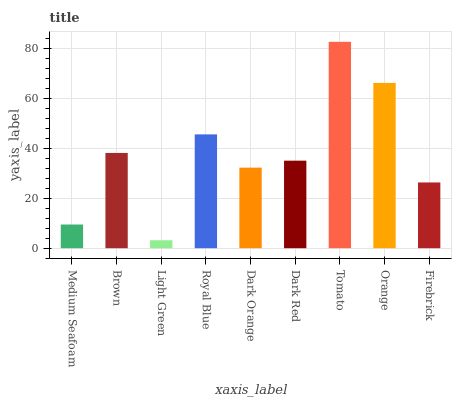Is Light Green the minimum?
Answer yes or no. Yes. Is Tomato the maximum?
Answer yes or no. Yes. Is Brown the minimum?
Answer yes or no. No. Is Brown the maximum?
Answer yes or no. No. Is Brown greater than Medium Seafoam?
Answer yes or no. Yes. Is Medium Seafoam less than Brown?
Answer yes or no. Yes. Is Medium Seafoam greater than Brown?
Answer yes or no. No. Is Brown less than Medium Seafoam?
Answer yes or no. No. Is Dark Red the high median?
Answer yes or no. Yes. Is Dark Red the low median?
Answer yes or no. Yes. Is Dark Orange the high median?
Answer yes or no. No. Is Firebrick the low median?
Answer yes or no. No. 